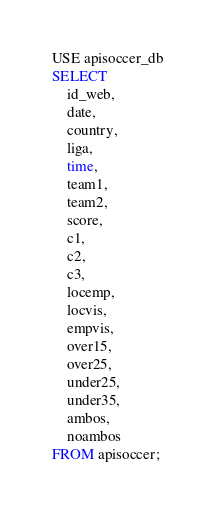Convert code to text. <code><loc_0><loc_0><loc_500><loc_500><_SQL_>USE apisoccer_db
SELECT 
    id_web,
	date,
    country,
    liga,
    time,
    team1,
    team2,
    score,
    c1,
    c2,
    c3,
    locemp,
    locvis,
    empvis,
    over15,
    over25,
    under25,
    under35,
    ambos,
    noambos
FROM apisoccer;</code> 